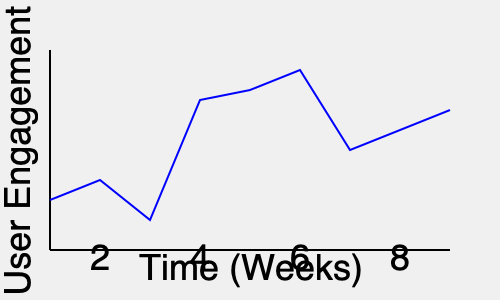Based on the app store analytics graph showing user engagement over time, when would be the most strategic time to release a major app update? To determine the best time for a major app update, we need to analyze the user engagement trend:

1. Observe the overall trend: The graph shows fluctuations in user engagement over 8 weeks.

2. Identify peak engagement: The highest engagement occurs around week 6.

3. Analyze the trend after the peak: There's a significant drop in engagement after week 6.

4. Consider update timing: Releasing an update when engagement is declining can help re-engage users.

5. Optimal timing: The best time to release a major update would be just after the engagement peak, around week 7.

6. Reasoning: This timing allows you to:
   a) Capitalize on the high user base from the recent peak.
   b) Potentially reverse the declining trend.
   c) Re-engage users who might be losing interest.

7. Additional consideration: Releasing at week 7 also gives time to prepare based on insights from the peak engagement period.
Answer: Week 7 